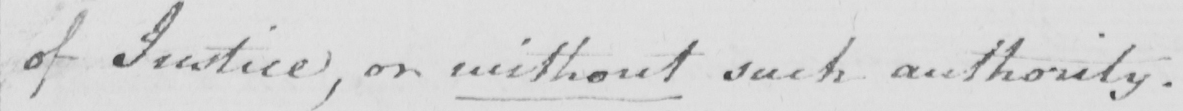Please transcribe the handwritten text in this image. of Justice , or without such authority . 